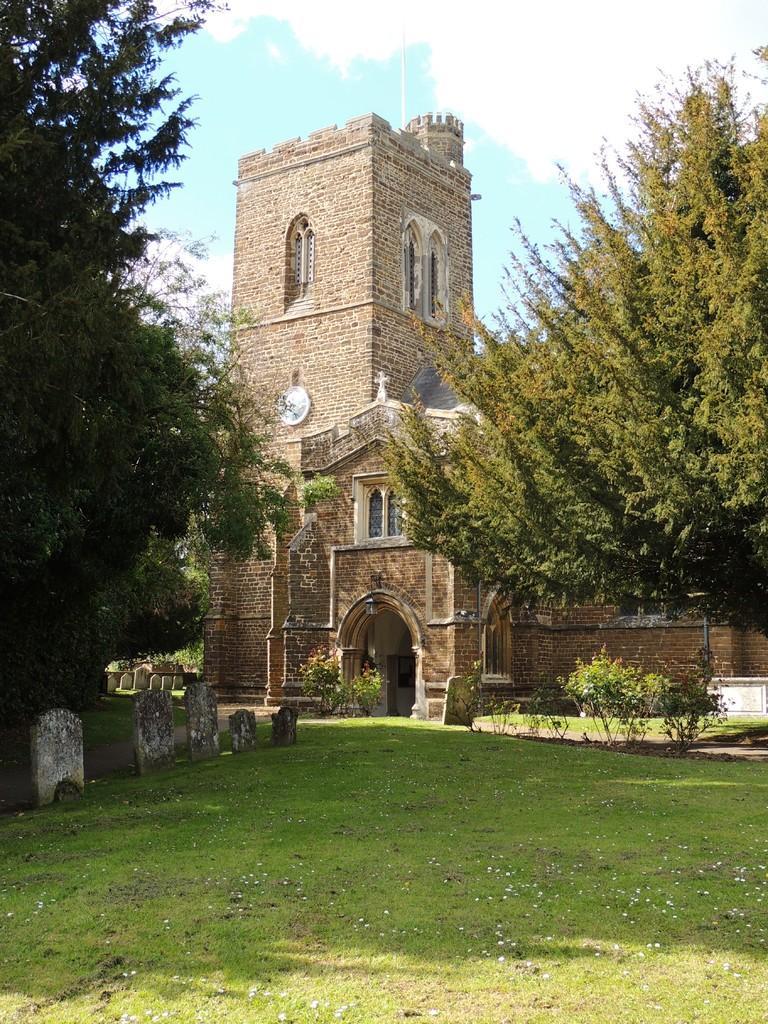In one or two sentences, can you explain what this image depicts? In this image there is a building, in front of the building there is a graveyard, there are trees and plants. In the background there is the sky. 